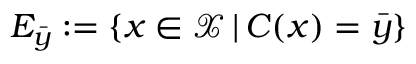<formula> <loc_0><loc_0><loc_500><loc_500>E _ { \bar { y } } \colon = \{ x \in \mathcal { X } \, | \, C ( x ) = \bar { y } \}</formula> 